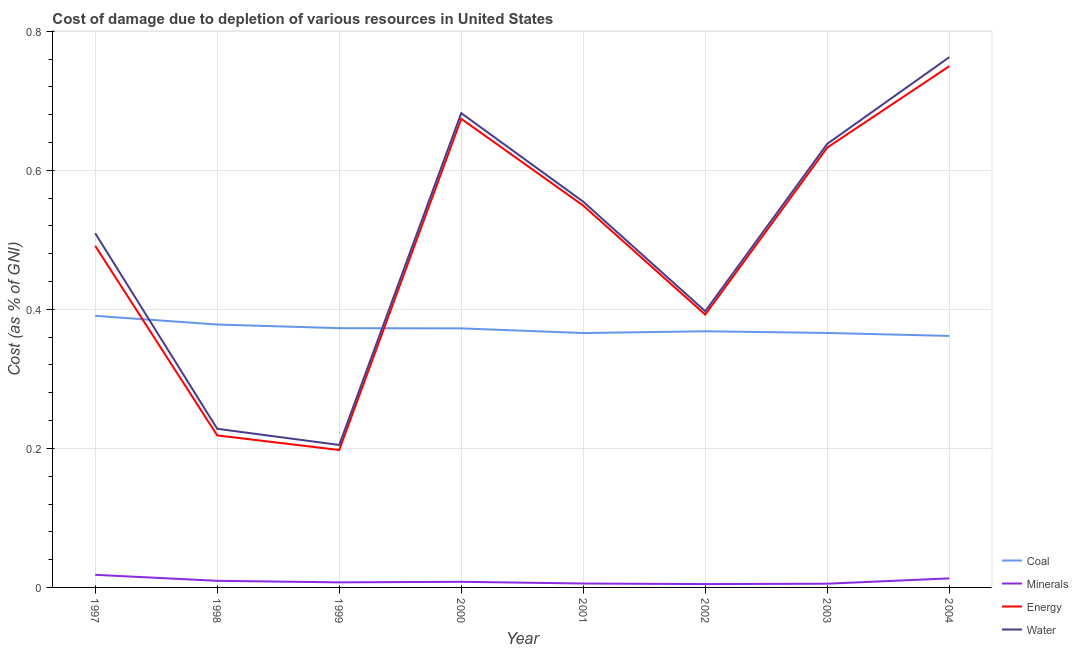What is the cost of damage due to depletion of coal in 2001?
Keep it short and to the point. 0.37. Across all years, what is the maximum cost of damage due to depletion of energy?
Give a very brief answer. 0.75. Across all years, what is the minimum cost of damage due to depletion of coal?
Offer a very short reply. 0.36. What is the total cost of damage due to depletion of water in the graph?
Give a very brief answer. 3.98. What is the difference between the cost of damage due to depletion of coal in 1999 and that in 2003?
Make the answer very short. 0.01. What is the difference between the cost of damage due to depletion of coal in 1997 and the cost of damage due to depletion of minerals in 2004?
Offer a very short reply. 0.38. What is the average cost of damage due to depletion of minerals per year?
Provide a short and direct response. 0.01. In the year 2004, what is the difference between the cost of damage due to depletion of minerals and cost of damage due to depletion of energy?
Make the answer very short. -0.74. In how many years, is the cost of damage due to depletion of energy greater than 0.36 %?
Offer a terse response. 6. What is the ratio of the cost of damage due to depletion of coal in 2002 to that in 2003?
Keep it short and to the point. 1.01. Is the cost of damage due to depletion of coal in 2000 less than that in 2001?
Make the answer very short. No. Is the difference between the cost of damage due to depletion of minerals in 1998 and 2000 greater than the difference between the cost of damage due to depletion of coal in 1998 and 2000?
Provide a short and direct response. No. What is the difference between the highest and the second highest cost of damage due to depletion of minerals?
Provide a short and direct response. 0.01. What is the difference between the highest and the lowest cost of damage due to depletion of coal?
Provide a succinct answer. 0.03. In how many years, is the cost of damage due to depletion of energy greater than the average cost of damage due to depletion of energy taken over all years?
Offer a very short reply. 5. Is the sum of the cost of damage due to depletion of coal in 2002 and 2004 greater than the maximum cost of damage due to depletion of water across all years?
Offer a terse response. No. Is it the case that in every year, the sum of the cost of damage due to depletion of minerals and cost of damage due to depletion of energy is greater than the sum of cost of damage due to depletion of coal and cost of damage due to depletion of water?
Offer a terse response. No. Does the cost of damage due to depletion of coal monotonically increase over the years?
Ensure brevity in your answer.  No. How many lines are there?
Make the answer very short. 4. How many years are there in the graph?
Your answer should be compact. 8. Does the graph contain any zero values?
Provide a short and direct response. No. How are the legend labels stacked?
Make the answer very short. Vertical. What is the title of the graph?
Keep it short and to the point. Cost of damage due to depletion of various resources in United States . What is the label or title of the X-axis?
Offer a terse response. Year. What is the label or title of the Y-axis?
Keep it short and to the point. Cost (as % of GNI). What is the Cost (as % of GNI) of Coal in 1997?
Ensure brevity in your answer.  0.39. What is the Cost (as % of GNI) of Minerals in 1997?
Your answer should be very brief. 0.02. What is the Cost (as % of GNI) in Energy in 1997?
Ensure brevity in your answer.  0.49. What is the Cost (as % of GNI) in Water in 1997?
Offer a very short reply. 0.51. What is the Cost (as % of GNI) of Coal in 1998?
Keep it short and to the point. 0.38. What is the Cost (as % of GNI) of Minerals in 1998?
Ensure brevity in your answer.  0.01. What is the Cost (as % of GNI) of Energy in 1998?
Offer a terse response. 0.22. What is the Cost (as % of GNI) of Water in 1998?
Provide a short and direct response. 0.23. What is the Cost (as % of GNI) of Coal in 1999?
Give a very brief answer. 0.37. What is the Cost (as % of GNI) of Minerals in 1999?
Provide a short and direct response. 0.01. What is the Cost (as % of GNI) of Energy in 1999?
Your answer should be very brief. 0.2. What is the Cost (as % of GNI) of Water in 1999?
Provide a succinct answer. 0.2. What is the Cost (as % of GNI) in Coal in 2000?
Your answer should be compact. 0.37. What is the Cost (as % of GNI) of Minerals in 2000?
Ensure brevity in your answer.  0.01. What is the Cost (as % of GNI) of Energy in 2000?
Keep it short and to the point. 0.67. What is the Cost (as % of GNI) of Water in 2000?
Give a very brief answer. 0.68. What is the Cost (as % of GNI) in Coal in 2001?
Offer a very short reply. 0.37. What is the Cost (as % of GNI) in Minerals in 2001?
Your response must be concise. 0.01. What is the Cost (as % of GNI) of Energy in 2001?
Your answer should be very brief. 0.55. What is the Cost (as % of GNI) of Water in 2001?
Your response must be concise. 0.55. What is the Cost (as % of GNI) of Coal in 2002?
Offer a very short reply. 0.37. What is the Cost (as % of GNI) of Minerals in 2002?
Offer a very short reply. 0. What is the Cost (as % of GNI) in Energy in 2002?
Your answer should be compact. 0.39. What is the Cost (as % of GNI) in Water in 2002?
Provide a succinct answer. 0.4. What is the Cost (as % of GNI) of Coal in 2003?
Make the answer very short. 0.37. What is the Cost (as % of GNI) of Minerals in 2003?
Provide a succinct answer. 0.01. What is the Cost (as % of GNI) of Energy in 2003?
Make the answer very short. 0.63. What is the Cost (as % of GNI) in Water in 2003?
Keep it short and to the point. 0.64. What is the Cost (as % of GNI) of Coal in 2004?
Offer a terse response. 0.36. What is the Cost (as % of GNI) of Minerals in 2004?
Make the answer very short. 0.01. What is the Cost (as % of GNI) in Energy in 2004?
Provide a short and direct response. 0.75. What is the Cost (as % of GNI) of Water in 2004?
Offer a very short reply. 0.76. Across all years, what is the maximum Cost (as % of GNI) in Coal?
Ensure brevity in your answer.  0.39. Across all years, what is the maximum Cost (as % of GNI) of Minerals?
Keep it short and to the point. 0.02. Across all years, what is the maximum Cost (as % of GNI) of Energy?
Give a very brief answer. 0.75. Across all years, what is the maximum Cost (as % of GNI) of Water?
Your answer should be very brief. 0.76. Across all years, what is the minimum Cost (as % of GNI) of Coal?
Offer a very short reply. 0.36. Across all years, what is the minimum Cost (as % of GNI) in Minerals?
Ensure brevity in your answer.  0. Across all years, what is the minimum Cost (as % of GNI) of Energy?
Give a very brief answer. 0.2. Across all years, what is the minimum Cost (as % of GNI) in Water?
Give a very brief answer. 0.2. What is the total Cost (as % of GNI) of Coal in the graph?
Give a very brief answer. 2.98. What is the total Cost (as % of GNI) in Minerals in the graph?
Make the answer very short. 0.07. What is the total Cost (as % of GNI) of Energy in the graph?
Make the answer very short. 3.91. What is the total Cost (as % of GNI) of Water in the graph?
Keep it short and to the point. 3.98. What is the difference between the Cost (as % of GNI) of Coal in 1997 and that in 1998?
Provide a short and direct response. 0.01. What is the difference between the Cost (as % of GNI) in Minerals in 1997 and that in 1998?
Provide a succinct answer. 0.01. What is the difference between the Cost (as % of GNI) of Energy in 1997 and that in 1998?
Your answer should be very brief. 0.27. What is the difference between the Cost (as % of GNI) in Water in 1997 and that in 1998?
Ensure brevity in your answer.  0.28. What is the difference between the Cost (as % of GNI) of Coal in 1997 and that in 1999?
Ensure brevity in your answer.  0.02. What is the difference between the Cost (as % of GNI) in Minerals in 1997 and that in 1999?
Make the answer very short. 0.01. What is the difference between the Cost (as % of GNI) of Energy in 1997 and that in 1999?
Offer a very short reply. 0.29. What is the difference between the Cost (as % of GNI) of Water in 1997 and that in 1999?
Keep it short and to the point. 0.3. What is the difference between the Cost (as % of GNI) of Coal in 1997 and that in 2000?
Keep it short and to the point. 0.02. What is the difference between the Cost (as % of GNI) in Energy in 1997 and that in 2000?
Give a very brief answer. -0.18. What is the difference between the Cost (as % of GNI) of Water in 1997 and that in 2000?
Keep it short and to the point. -0.17. What is the difference between the Cost (as % of GNI) in Coal in 1997 and that in 2001?
Your answer should be very brief. 0.02. What is the difference between the Cost (as % of GNI) in Minerals in 1997 and that in 2001?
Your answer should be compact. 0.01. What is the difference between the Cost (as % of GNI) in Energy in 1997 and that in 2001?
Your answer should be compact. -0.06. What is the difference between the Cost (as % of GNI) in Water in 1997 and that in 2001?
Ensure brevity in your answer.  -0.05. What is the difference between the Cost (as % of GNI) in Coal in 1997 and that in 2002?
Your answer should be compact. 0.02. What is the difference between the Cost (as % of GNI) in Minerals in 1997 and that in 2002?
Make the answer very short. 0.01. What is the difference between the Cost (as % of GNI) in Energy in 1997 and that in 2002?
Make the answer very short. 0.1. What is the difference between the Cost (as % of GNI) of Water in 1997 and that in 2002?
Keep it short and to the point. 0.11. What is the difference between the Cost (as % of GNI) in Coal in 1997 and that in 2003?
Offer a terse response. 0.02. What is the difference between the Cost (as % of GNI) in Minerals in 1997 and that in 2003?
Offer a very short reply. 0.01. What is the difference between the Cost (as % of GNI) in Energy in 1997 and that in 2003?
Provide a succinct answer. -0.14. What is the difference between the Cost (as % of GNI) of Water in 1997 and that in 2003?
Your answer should be very brief. -0.13. What is the difference between the Cost (as % of GNI) in Coal in 1997 and that in 2004?
Provide a succinct answer. 0.03. What is the difference between the Cost (as % of GNI) of Minerals in 1997 and that in 2004?
Ensure brevity in your answer.  0.01. What is the difference between the Cost (as % of GNI) of Energy in 1997 and that in 2004?
Give a very brief answer. -0.26. What is the difference between the Cost (as % of GNI) in Water in 1997 and that in 2004?
Offer a very short reply. -0.25. What is the difference between the Cost (as % of GNI) of Coal in 1998 and that in 1999?
Give a very brief answer. 0.01. What is the difference between the Cost (as % of GNI) of Minerals in 1998 and that in 1999?
Ensure brevity in your answer.  0. What is the difference between the Cost (as % of GNI) of Energy in 1998 and that in 1999?
Provide a succinct answer. 0.02. What is the difference between the Cost (as % of GNI) of Water in 1998 and that in 1999?
Your answer should be very brief. 0.02. What is the difference between the Cost (as % of GNI) of Coal in 1998 and that in 2000?
Your answer should be very brief. 0.01. What is the difference between the Cost (as % of GNI) in Minerals in 1998 and that in 2000?
Your response must be concise. 0. What is the difference between the Cost (as % of GNI) of Energy in 1998 and that in 2000?
Your answer should be compact. -0.46. What is the difference between the Cost (as % of GNI) in Water in 1998 and that in 2000?
Your response must be concise. -0.45. What is the difference between the Cost (as % of GNI) of Coal in 1998 and that in 2001?
Your answer should be very brief. 0.01. What is the difference between the Cost (as % of GNI) of Minerals in 1998 and that in 2001?
Ensure brevity in your answer.  0. What is the difference between the Cost (as % of GNI) in Energy in 1998 and that in 2001?
Provide a succinct answer. -0.33. What is the difference between the Cost (as % of GNI) in Water in 1998 and that in 2001?
Keep it short and to the point. -0.33. What is the difference between the Cost (as % of GNI) of Coal in 1998 and that in 2002?
Offer a very short reply. 0.01. What is the difference between the Cost (as % of GNI) of Minerals in 1998 and that in 2002?
Keep it short and to the point. 0. What is the difference between the Cost (as % of GNI) of Energy in 1998 and that in 2002?
Provide a short and direct response. -0.17. What is the difference between the Cost (as % of GNI) of Water in 1998 and that in 2002?
Your answer should be compact. -0.17. What is the difference between the Cost (as % of GNI) of Coal in 1998 and that in 2003?
Your response must be concise. 0.01. What is the difference between the Cost (as % of GNI) in Minerals in 1998 and that in 2003?
Your response must be concise. 0. What is the difference between the Cost (as % of GNI) of Energy in 1998 and that in 2003?
Provide a short and direct response. -0.41. What is the difference between the Cost (as % of GNI) in Water in 1998 and that in 2003?
Your answer should be very brief. -0.41. What is the difference between the Cost (as % of GNI) in Coal in 1998 and that in 2004?
Offer a very short reply. 0.02. What is the difference between the Cost (as % of GNI) of Minerals in 1998 and that in 2004?
Keep it short and to the point. -0. What is the difference between the Cost (as % of GNI) in Energy in 1998 and that in 2004?
Ensure brevity in your answer.  -0.53. What is the difference between the Cost (as % of GNI) of Water in 1998 and that in 2004?
Keep it short and to the point. -0.53. What is the difference between the Cost (as % of GNI) of Coal in 1999 and that in 2000?
Offer a terse response. 0. What is the difference between the Cost (as % of GNI) of Minerals in 1999 and that in 2000?
Your answer should be compact. -0. What is the difference between the Cost (as % of GNI) of Energy in 1999 and that in 2000?
Provide a succinct answer. -0.48. What is the difference between the Cost (as % of GNI) of Water in 1999 and that in 2000?
Keep it short and to the point. -0.48. What is the difference between the Cost (as % of GNI) of Coal in 1999 and that in 2001?
Give a very brief answer. 0.01. What is the difference between the Cost (as % of GNI) of Minerals in 1999 and that in 2001?
Your answer should be compact. 0. What is the difference between the Cost (as % of GNI) of Energy in 1999 and that in 2001?
Your answer should be compact. -0.35. What is the difference between the Cost (as % of GNI) in Water in 1999 and that in 2001?
Offer a very short reply. -0.35. What is the difference between the Cost (as % of GNI) in Coal in 1999 and that in 2002?
Provide a succinct answer. 0. What is the difference between the Cost (as % of GNI) in Minerals in 1999 and that in 2002?
Your response must be concise. 0. What is the difference between the Cost (as % of GNI) in Energy in 1999 and that in 2002?
Provide a succinct answer. -0.19. What is the difference between the Cost (as % of GNI) of Water in 1999 and that in 2002?
Offer a very short reply. -0.19. What is the difference between the Cost (as % of GNI) of Coal in 1999 and that in 2003?
Offer a terse response. 0.01. What is the difference between the Cost (as % of GNI) in Minerals in 1999 and that in 2003?
Your answer should be compact. 0. What is the difference between the Cost (as % of GNI) in Energy in 1999 and that in 2003?
Offer a terse response. -0.44. What is the difference between the Cost (as % of GNI) of Water in 1999 and that in 2003?
Keep it short and to the point. -0.43. What is the difference between the Cost (as % of GNI) in Coal in 1999 and that in 2004?
Your answer should be compact. 0.01. What is the difference between the Cost (as % of GNI) in Minerals in 1999 and that in 2004?
Keep it short and to the point. -0.01. What is the difference between the Cost (as % of GNI) in Energy in 1999 and that in 2004?
Your response must be concise. -0.55. What is the difference between the Cost (as % of GNI) in Water in 1999 and that in 2004?
Offer a terse response. -0.56. What is the difference between the Cost (as % of GNI) of Coal in 2000 and that in 2001?
Offer a terse response. 0.01. What is the difference between the Cost (as % of GNI) of Minerals in 2000 and that in 2001?
Keep it short and to the point. 0. What is the difference between the Cost (as % of GNI) in Energy in 2000 and that in 2001?
Ensure brevity in your answer.  0.12. What is the difference between the Cost (as % of GNI) of Water in 2000 and that in 2001?
Offer a terse response. 0.13. What is the difference between the Cost (as % of GNI) in Coal in 2000 and that in 2002?
Keep it short and to the point. 0. What is the difference between the Cost (as % of GNI) in Minerals in 2000 and that in 2002?
Give a very brief answer. 0. What is the difference between the Cost (as % of GNI) in Energy in 2000 and that in 2002?
Provide a succinct answer. 0.28. What is the difference between the Cost (as % of GNI) of Water in 2000 and that in 2002?
Make the answer very short. 0.28. What is the difference between the Cost (as % of GNI) in Coal in 2000 and that in 2003?
Your answer should be compact. 0.01. What is the difference between the Cost (as % of GNI) in Minerals in 2000 and that in 2003?
Your answer should be very brief. 0. What is the difference between the Cost (as % of GNI) of Energy in 2000 and that in 2003?
Provide a succinct answer. 0.04. What is the difference between the Cost (as % of GNI) of Water in 2000 and that in 2003?
Make the answer very short. 0.04. What is the difference between the Cost (as % of GNI) of Coal in 2000 and that in 2004?
Ensure brevity in your answer.  0.01. What is the difference between the Cost (as % of GNI) of Minerals in 2000 and that in 2004?
Provide a short and direct response. -0. What is the difference between the Cost (as % of GNI) in Energy in 2000 and that in 2004?
Your answer should be compact. -0.08. What is the difference between the Cost (as % of GNI) of Water in 2000 and that in 2004?
Ensure brevity in your answer.  -0.08. What is the difference between the Cost (as % of GNI) of Coal in 2001 and that in 2002?
Provide a succinct answer. -0. What is the difference between the Cost (as % of GNI) in Minerals in 2001 and that in 2002?
Keep it short and to the point. 0. What is the difference between the Cost (as % of GNI) of Energy in 2001 and that in 2002?
Your response must be concise. 0.16. What is the difference between the Cost (as % of GNI) of Water in 2001 and that in 2002?
Your answer should be very brief. 0.16. What is the difference between the Cost (as % of GNI) of Coal in 2001 and that in 2003?
Provide a succinct answer. -0. What is the difference between the Cost (as % of GNI) in Minerals in 2001 and that in 2003?
Your answer should be very brief. 0. What is the difference between the Cost (as % of GNI) in Energy in 2001 and that in 2003?
Offer a very short reply. -0.08. What is the difference between the Cost (as % of GNI) in Water in 2001 and that in 2003?
Make the answer very short. -0.08. What is the difference between the Cost (as % of GNI) in Coal in 2001 and that in 2004?
Ensure brevity in your answer.  0. What is the difference between the Cost (as % of GNI) in Minerals in 2001 and that in 2004?
Offer a very short reply. -0.01. What is the difference between the Cost (as % of GNI) of Energy in 2001 and that in 2004?
Ensure brevity in your answer.  -0.2. What is the difference between the Cost (as % of GNI) in Water in 2001 and that in 2004?
Offer a terse response. -0.21. What is the difference between the Cost (as % of GNI) of Coal in 2002 and that in 2003?
Give a very brief answer. 0. What is the difference between the Cost (as % of GNI) in Minerals in 2002 and that in 2003?
Ensure brevity in your answer.  -0. What is the difference between the Cost (as % of GNI) in Energy in 2002 and that in 2003?
Offer a very short reply. -0.24. What is the difference between the Cost (as % of GNI) in Water in 2002 and that in 2003?
Provide a short and direct response. -0.24. What is the difference between the Cost (as % of GNI) in Coal in 2002 and that in 2004?
Your answer should be very brief. 0.01. What is the difference between the Cost (as % of GNI) of Minerals in 2002 and that in 2004?
Your response must be concise. -0.01. What is the difference between the Cost (as % of GNI) of Energy in 2002 and that in 2004?
Offer a very short reply. -0.36. What is the difference between the Cost (as % of GNI) of Water in 2002 and that in 2004?
Your answer should be compact. -0.37. What is the difference between the Cost (as % of GNI) in Coal in 2003 and that in 2004?
Keep it short and to the point. 0. What is the difference between the Cost (as % of GNI) of Minerals in 2003 and that in 2004?
Ensure brevity in your answer.  -0.01. What is the difference between the Cost (as % of GNI) in Energy in 2003 and that in 2004?
Your response must be concise. -0.12. What is the difference between the Cost (as % of GNI) of Water in 2003 and that in 2004?
Keep it short and to the point. -0.12. What is the difference between the Cost (as % of GNI) of Coal in 1997 and the Cost (as % of GNI) of Minerals in 1998?
Your answer should be very brief. 0.38. What is the difference between the Cost (as % of GNI) in Coal in 1997 and the Cost (as % of GNI) in Energy in 1998?
Keep it short and to the point. 0.17. What is the difference between the Cost (as % of GNI) of Coal in 1997 and the Cost (as % of GNI) of Water in 1998?
Your response must be concise. 0.16. What is the difference between the Cost (as % of GNI) in Minerals in 1997 and the Cost (as % of GNI) in Energy in 1998?
Provide a succinct answer. -0.2. What is the difference between the Cost (as % of GNI) of Minerals in 1997 and the Cost (as % of GNI) of Water in 1998?
Give a very brief answer. -0.21. What is the difference between the Cost (as % of GNI) in Energy in 1997 and the Cost (as % of GNI) in Water in 1998?
Offer a terse response. 0.26. What is the difference between the Cost (as % of GNI) in Coal in 1997 and the Cost (as % of GNI) in Minerals in 1999?
Your response must be concise. 0.38. What is the difference between the Cost (as % of GNI) of Coal in 1997 and the Cost (as % of GNI) of Energy in 1999?
Your answer should be very brief. 0.19. What is the difference between the Cost (as % of GNI) in Coal in 1997 and the Cost (as % of GNI) in Water in 1999?
Your answer should be very brief. 0.19. What is the difference between the Cost (as % of GNI) in Minerals in 1997 and the Cost (as % of GNI) in Energy in 1999?
Provide a short and direct response. -0.18. What is the difference between the Cost (as % of GNI) of Minerals in 1997 and the Cost (as % of GNI) of Water in 1999?
Make the answer very short. -0.19. What is the difference between the Cost (as % of GNI) in Energy in 1997 and the Cost (as % of GNI) in Water in 1999?
Provide a short and direct response. 0.29. What is the difference between the Cost (as % of GNI) of Coal in 1997 and the Cost (as % of GNI) of Minerals in 2000?
Your answer should be very brief. 0.38. What is the difference between the Cost (as % of GNI) in Coal in 1997 and the Cost (as % of GNI) in Energy in 2000?
Provide a short and direct response. -0.28. What is the difference between the Cost (as % of GNI) of Coal in 1997 and the Cost (as % of GNI) of Water in 2000?
Your response must be concise. -0.29. What is the difference between the Cost (as % of GNI) of Minerals in 1997 and the Cost (as % of GNI) of Energy in 2000?
Ensure brevity in your answer.  -0.66. What is the difference between the Cost (as % of GNI) in Minerals in 1997 and the Cost (as % of GNI) in Water in 2000?
Provide a succinct answer. -0.66. What is the difference between the Cost (as % of GNI) of Energy in 1997 and the Cost (as % of GNI) of Water in 2000?
Make the answer very short. -0.19. What is the difference between the Cost (as % of GNI) of Coal in 1997 and the Cost (as % of GNI) of Minerals in 2001?
Your answer should be compact. 0.39. What is the difference between the Cost (as % of GNI) of Coal in 1997 and the Cost (as % of GNI) of Energy in 2001?
Offer a very short reply. -0.16. What is the difference between the Cost (as % of GNI) in Coal in 1997 and the Cost (as % of GNI) in Water in 2001?
Make the answer very short. -0.16. What is the difference between the Cost (as % of GNI) in Minerals in 1997 and the Cost (as % of GNI) in Energy in 2001?
Ensure brevity in your answer.  -0.53. What is the difference between the Cost (as % of GNI) in Minerals in 1997 and the Cost (as % of GNI) in Water in 2001?
Ensure brevity in your answer.  -0.54. What is the difference between the Cost (as % of GNI) in Energy in 1997 and the Cost (as % of GNI) in Water in 2001?
Offer a terse response. -0.06. What is the difference between the Cost (as % of GNI) of Coal in 1997 and the Cost (as % of GNI) of Minerals in 2002?
Provide a short and direct response. 0.39. What is the difference between the Cost (as % of GNI) of Coal in 1997 and the Cost (as % of GNI) of Energy in 2002?
Your answer should be compact. -0. What is the difference between the Cost (as % of GNI) of Coal in 1997 and the Cost (as % of GNI) of Water in 2002?
Offer a terse response. -0.01. What is the difference between the Cost (as % of GNI) in Minerals in 1997 and the Cost (as % of GNI) in Energy in 2002?
Offer a very short reply. -0.37. What is the difference between the Cost (as % of GNI) in Minerals in 1997 and the Cost (as % of GNI) in Water in 2002?
Offer a very short reply. -0.38. What is the difference between the Cost (as % of GNI) in Energy in 1997 and the Cost (as % of GNI) in Water in 2002?
Provide a short and direct response. 0.09. What is the difference between the Cost (as % of GNI) of Coal in 1997 and the Cost (as % of GNI) of Minerals in 2003?
Make the answer very short. 0.39. What is the difference between the Cost (as % of GNI) of Coal in 1997 and the Cost (as % of GNI) of Energy in 2003?
Give a very brief answer. -0.24. What is the difference between the Cost (as % of GNI) in Coal in 1997 and the Cost (as % of GNI) in Water in 2003?
Offer a very short reply. -0.25. What is the difference between the Cost (as % of GNI) of Minerals in 1997 and the Cost (as % of GNI) of Energy in 2003?
Offer a terse response. -0.61. What is the difference between the Cost (as % of GNI) in Minerals in 1997 and the Cost (as % of GNI) in Water in 2003?
Provide a succinct answer. -0.62. What is the difference between the Cost (as % of GNI) of Energy in 1997 and the Cost (as % of GNI) of Water in 2003?
Provide a short and direct response. -0.15. What is the difference between the Cost (as % of GNI) in Coal in 1997 and the Cost (as % of GNI) in Minerals in 2004?
Your answer should be compact. 0.38. What is the difference between the Cost (as % of GNI) of Coal in 1997 and the Cost (as % of GNI) of Energy in 2004?
Make the answer very short. -0.36. What is the difference between the Cost (as % of GNI) in Coal in 1997 and the Cost (as % of GNI) in Water in 2004?
Keep it short and to the point. -0.37. What is the difference between the Cost (as % of GNI) of Minerals in 1997 and the Cost (as % of GNI) of Energy in 2004?
Your answer should be very brief. -0.73. What is the difference between the Cost (as % of GNI) in Minerals in 1997 and the Cost (as % of GNI) in Water in 2004?
Your answer should be very brief. -0.74. What is the difference between the Cost (as % of GNI) of Energy in 1997 and the Cost (as % of GNI) of Water in 2004?
Give a very brief answer. -0.27. What is the difference between the Cost (as % of GNI) in Coal in 1998 and the Cost (as % of GNI) in Minerals in 1999?
Offer a terse response. 0.37. What is the difference between the Cost (as % of GNI) in Coal in 1998 and the Cost (as % of GNI) in Energy in 1999?
Provide a succinct answer. 0.18. What is the difference between the Cost (as % of GNI) of Coal in 1998 and the Cost (as % of GNI) of Water in 1999?
Offer a very short reply. 0.17. What is the difference between the Cost (as % of GNI) of Minerals in 1998 and the Cost (as % of GNI) of Energy in 1999?
Offer a very short reply. -0.19. What is the difference between the Cost (as % of GNI) in Minerals in 1998 and the Cost (as % of GNI) in Water in 1999?
Offer a very short reply. -0.2. What is the difference between the Cost (as % of GNI) in Energy in 1998 and the Cost (as % of GNI) in Water in 1999?
Your answer should be compact. 0.01. What is the difference between the Cost (as % of GNI) in Coal in 1998 and the Cost (as % of GNI) in Minerals in 2000?
Ensure brevity in your answer.  0.37. What is the difference between the Cost (as % of GNI) in Coal in 1998 and the Cost (as % of GNI) in Energy in 2000?
Provide a succinct answer. -0.3. What is the difference between the Cost (as % of GNI) in Coal in 1998 and the Cost (as % of GNI) in Water in 2000?
Ensure brevity in your answer.  -0.3. What is the difference between the Cost (as % of GNI) of Minerals in 1998 and the Cost (as % of GNI) of Energy in 2000?
Ensure brevity in your answer.  -0.66. What is the difference between the Cost (as % of GNI) of Minerals in 1998 and the Cost (as % of GNI) of Water in 2000?
Provide a short and direct response. -0.67. What is the difference between the Cost (as % of GNI) of Energy in 1998 and the Cost (as % of GNI) of Water in 2000?
Give a very brief answer. -0.46. What is the difference between the Cost (as % of GNI) in Coal in 1998 and the Cost (as % of GNI) in Minerals in 2001?
Offer a terse response. 0.37. What is the difference between the Cost (as % of GNI) in Coal in 1998 and the Cost (as % of GNI) in Energy in 2001?
Make the answer very short. -0.17. What is the difference between the Cost (as % of GNI) in Coal in 1998 and the Cost (as % of GNI) in Water in 2001?
Give a very brief answer. -0.18. What is the difference between the Cost (as % of GNI) of Minerals in 1998 and the Cost (as % of GNI) of Energy in 2001?
Offer a terse response. -0.54. What is the difference between the Cost (as % of GNI) in Minerals in 1998 and the Cost (as % of GNI) in Water in 2001?
Your answer should be very brief. -0.55. What is the difference between the Cost (as % of GNI) in Energy in 1998 and the Cost (as % of GNI) in Water in 2001?
Ensure brevity in your answer.  -0.34. What is the difference between the Cost (as % of GNI) in Coal in 1998 and the Cost (as % of GNI) in Minerals in 2002?
Your answer should be compact. 0.37. What is the difference between the Cost (as % of GNI) of Coal in 1998 and the Cost (as % of GNI) of Energy in 2002?
Offer a very short reply. -0.01. What is the difference between the Cost (as % of GNI) in Coal in 1998 and the Cost (as % of GNI) in Water in 2002?
Make the answer very short. -0.02. What is the difference between the Cost (as % of GNI) in Minerals in 1998 and the Cost (as % of GNI) in Energy in 2002?
Offer a terse response. -0.38. What is the difference between the Cost (as % of GNI) in Minerals in 1998 and the Cost (as % of GNI) in Water in 2002?
Keep it short and to the point. -0.39. What is the difference between the Cost (as % of GNI) of Energy in 1998 and the Cost (as % of GNI) of Water in 2002?
Make the answer very short. -0.18. What is the difference between the Cost (as % of GNI) in Coal in 1998 and the Cost (as % of GNI) in Minerals in 2003?
Provide a short and direct response. 0.37. What is the difference between the Cost (as % of GNI) in Coal in 1998 and the Cost (as % of GNI) in Energy in 2003?
Give a very brief answer. -0.25. What is the difference between the Cost (as % of GNI) of Coal in 1998 and the Cost (as % of GNI) of Water in 2003?
Provide a succinct answer. -0.26. What is the difference between the Cost (as % of GNI) of Minerals in 1998 and the Cost (as % of GNI) of Energy in 2003?
Offer a terse response. -0.62. What is the difference between the Cost (as % of GNI) in Minerals in 1998 and the Cost (as % of GNI) in Water in 2003?
Ensure brevity in your answer.  -0.63. What is the difference between the Cost (as % of GNI) of Energy in 1998 and the Cost (as % of GNI) of Water in 2003?
Make the answer very short. -0.42. What is the difference between the Cost (as % of GNI) of Coal in 1998 and the Cost (as % of GNI) of Minerals in 2004?
Provide a succinct answer. 0.37. What is the difference between the Cost (as % of GNI) of Coal in 1998 and the Cost (as % of GNI) of Energy in 2004?
Make the answer very short. -0.37. What is the difference between the Cost (as % of GNI) of Coal in 1998 and the Cost (as % of GNI) of Water in 2004?
Your answer should be very brief. -0.38. What is the difference between the Cost (as % of GNI) of Minerals in 1998 and the Cost (as % of GNI) of Energy in 2004?
Your response must be concise. -0.74. What is the difference between the Cost (as % of GNI) of Minerals in 1998 and the Cost (as % of GNI) of Water in 2004?
Give a very brief answer. -0.75. What is the difference between the Cost (as % of GNI) in Energy in 1998 and the Cost (as % of GNI) in Water in 2004?
Provide a short and direct response. -0.54. What is the difference between the Cost (as % of GNI) in Coal in 1999 and the Cost (as % of GNI) in Minerals in 2000?
Offer a very short reply. 0.36. What is the difference between the Cost (as % of GNI) of Coal in 1999 and the Cost (as % of GNI) of Energy in 2000?
Give a very brief answer. -0.3. What is the difference between the Cost (as % of GNI) of Coal in 1999 and the Cost (as % of GNI) of Water in 2000?
Offer a very short reply. -0.31. What is the difference between the Cost (as % of GNI) in Minerals in 1999 and the Cost (as % of GNI) in Energy in 2000?
Provide a short and direct response. -0.67. What is the difference between the Cost (as % of GNI) in Minerals in 1999 and the Cost (as % of GNI) in Water in 2000?
Ensure brevity in your answer.  -0.67. What is the difference between the Cost (as % of GNI) of Energy in 1999 and the Cost (as % of GNI) of Water in 2000?
Ensure brevity in your answer.  -0.48. What is the difference between the Cost (as % of GNI) of Coal in 1999 and the Cost (as % of GNI) of Minerals in 2001?
Provide a short and direct response. 0.37. What is the difference between the Cost (as % of GNI) of Coal in 1999 and the Cost (as % of GNI) of Energy in 2001?
Provide a short and direct response. -0.18. What is the difference between the Cost (as % of GNI) in Coal in 1999 and the Cost (as % of GNI) in Water in 2001?
Ensure brevity in your answer.  -0.18. What is the difference between the Cost (as % of GNI) of Minerals in 1999 and the Cost (as % of GNI) of Energy in 2001?
Your answer should be compact. -0.54. What is the difference between the Cost (as % of GNI) in Minerals in 1999 and the Cost (as % of GNI) in Water in 2001?
Your answer should be very brief. -0.55. What is the difference between the Cost (as % of GNI) of Energy in 1999 and the Cost (as % of GNI) of Water in 2001?
Your answer should be compact. -0.36. What is the difference between the Cost (as % of GNI) of Coal in 1999 and the Cost (as % of GNI) of Minerals in 2002?
Ensure brevity in your answer.  0.37. What is the difference between the Cost (as % of GNI) of Coal in 1999 and the Cost (as % of GNI) of Energy in 2002?
Ensure brevity in your answer.  -0.02. What is the difference between the Cost (as % of GNI) in Coal in 1999 and the Cost (as % of GNI) in Water in 2002?
Provide a short and direct response. -0.02. What is the difference between the Cost (as % of GNI) in Minerals in 1999 and the Cost (as % of GNI) in Energy in 2002?
Make the answer very short. -0.39. What is the difference between the Cost (as % of GNI) of Minerals in 1999 and the Cost (as % of GNI) of Water in 2002?
Offer a terse response. -0.39. What is the difference between the Cost (as % of GNI) of Energy in 1999 and the Cost (as % of GNI) of Water in 2002?
Provide a succinct answer. -0.2. What is the difference between the Cost (as % of GNI) of Coal in 1999 and the Cost (as % of GNI) of Minerals in 2003?
Keep it short and to the point. 0.37. What is the difference between the Cost (as % of GNI) of Coal in 1999 and the Cost (as % of GNI) of Energy in 2003?
Offer a terse response. -0.26. What is the difference between the Cost (as % of GNI) of Coal in 1999 and the Cost (as % of GNI) of Water in 2003?
Provide a succinct answer. -0.27. What is the difference between the Cost (as % of GNI) of Minerals in 1999 and the Cost (as % of GNI) of Energy in 2003?
Your answer should be compact. -0.63. What is the difference between the Cost (as % of GNI) in Minerals in 1999 and the Cost (as % of GNI) in Water in 2003?
Provide a short and direct response. -0.63. What is the difference between the Cost (as % of GNI) of Energy in 1999 and the Cost (as % of GNI) of Water in 2003?
Provide a short and direct response. -0.44. What is the difference between the Cost (as % of GNI) of Coal in 1999 and the Cost (as % of GNI) of Minerals in 2004?
Your answer should be compact. 0.36. What is the difference between the Cost (as % of GNI) in Coal in 1999 and the Cost (as % of GNI) in Energy in 2004?
Offer a terse response. -0.38. What is the difference between the Cost (as % of GNI) of Coal in 1999 and the Cost (as % of GNI) of Water in 2004?
Give a very brief answer. -0.39. What is the difference between the Cost (as % of GNI) in Minerals in 1999 and the Cost (as % of GNI) in Energy in 2004?
Provide a short and direct response. -0.74. What is the difference between the Cost (as % of GNI) of Minerals in 1999 and the Cost (as % of GNI) of Water in 2004?
Your answer should be compact. -0.76. What is the difference between the Cost (as % of GNI) of Energy in 1999 and the Cost (as % of GNI) of Water in 2004?
Keep it short and to the point. -0.57. What is the difference between the Cost (as % of GNI) in Coal in 2000 and the Cost (as % of GNI) in Minerals in 2001?
Your answer should be compact. 0.37. What is the difference between the Cost (as % of GNI) in Coal in 2000 and the Cost (as % of GNI) in Energy in 2001?
Keep it short and to the point. -0.18. What is the difference between the Cost (as % of GNI) of Coal in 2000 and the Cost (as % of GNI) of Water in 2001?
Provide a short and direct response. -0.18. What is the difference between the Cost (as % of GNI) of Minerals in 2000 and the Cost (as % of GNI) of Energy in 2001?
Your response must be concise. -0.54. What is the difference between the Cost (as % of GNI) in Minerals in 2000 and the Cost (as % of GNI) in Water in 2001?
Offer a terse response. -0.55. What is the difference between the Cost (as % of GNI) of Energy in 2000 and the Cost (as % of GNI) of Water in 2001?
Your answer should be compact. 0.12. What is the difference between the Cost (as % of GNI) in Coal in 2000 and the Cost (as % of GNI) in Minerals in 2002?
Make the answer very short. 0.37. What is the difference between the Cost (as % of GNI) of Coal in 2000 and the Cost (as % of GNI) of Energy in 2002?
Make the answer very short. -0.02. What is the difference between the Cost (as % of GNI) of Coal in 2000 and the Cost (as % of GNI) of Water in 2002?
Your answer should be very brief. -0.02. What is the difference between the Cost (as % of GNI) in Minerals in 2000 and the Cost (as % of GNI) in Energy in 2002?
Your answer should be compact. -0.38. What is the difference between the Cost (as % of GNI) in Minerals in 2000 and the Cost (as % of GNI) in Water in 2002?
Your answer should be compact. -0.39. What is the difference between the Cost (as % of GNI) of Energy in 2000 and the Cost (as % of GNI) of Water in 2002?
Your response must be concise. 0.28. What is the difference between the Cost (as % of GNI) of Coal in 2000 and the Cost (as % of GNI) of Minerals in 2003?
Keep it short and to the point. 0.37. What is the difference between the Cost (as % of GNI) in Coal in 2000 and the Cost (as % of GNI) in Energy in 2003?
Provide a short and direct response. -0.26. What is the difference between the Cost (as % of GNI) in Coal in 2000 and the Cost (as % of GNI) in Water in 2003?
Offer a terse response. -0.27. What is the difference between the Cost (as % of GNI) in Minerals in 2000 and the Cost (as % of GNI) in Energy in 2003?
Your answer should be very brief. -0.62. What is the difference between the Cost (as % of GNI) in Minerals in 2000 and the Cost (as % of GNI) in Water in 2003?
Make the answer very short. -0.63. What is the difference between the Cost (as % of GNI) of Energy in 2000 and the Cost (as % of GNI) of Water in 2003?
Offer a terse response. 0.04. What is the difference between the Cost (as % of GNI) of Coal in 2000 and the Cost (as % of GNI) of Minerals in 2004?
Your answer should be compact. 0.36. What is the difference between the Cost (as % of GNI) of Coal in 2000 and the Cost (as % of GNI) of Energy in 2004?
Offer a very short reply. -0.38. What is the difference between the Cost (as % of GNI) of Coal in 2000 and the Cost (as % of GNI) of Water in 2004?
Ensure brevity in your answer.  -0.39. What is the difference between the Cost (as % of GNI) of Minerals in 2000 and the Cost (as % of GNI) of Energy in 2004?
Your answer should be compact. -0.74. What is the difference between the Cost (as % of GNI) of Minerals in 2000 and the Cost (as % of GNI) of Water in 2004?
Provide a short and direct response. -0.75. What is the difference between the Cost (as % of GNI) of Energy in 2000 and the Cost (as % of GNI) of Water in 2004?
Your response must be concise. -0.09. What is the difference between the Cost (as % of GNI) in Coal in 2001 and the Cost (as % of GNI) in Minerals in 2002?
Offer a very short reply. 0.36. What is the difference between the Cost (as % of GNI) in Coal in 2001 and the Cost (as % of GNI) in Energy in 2002?
Give a very brief answer. -0.03. What is the difference between the Cost (as % of GNI) in Coal in 2001 and the Cost (as % of GNI) in Water in 2002?
Your answer should be compact. -0.03. What is the difference between the Cost (as % of GNI) of Minerals in 2001 and the Cost (as % of GNI) of Energy in 2002?
Give a very brief answer. -0.39. What is the difference between the Cost (as % of GNI) of Minerals in 2001 and the Cost (as % of GNI) of Water in 2002?
Make the answer very short. -0.39. What is the difference between the Cost (as % of GNI) of Energy in 2001 and the Cost (as % of GNI) of Water in 2002?
Give a very brief answer. 0.15. What is the difference between the Cost (as % of GNI) of Coal in 2001 and the Cost (as % of GNI) of Minerals in 2003?
Your response must be concise. 0.36. What is the difference between the Cost (as % of GNI) in Coal in 2001 and the Cost (as % of GNI) in Energy in 2003?
Your response must be concise. -0.27. What is the difference between the Cost (as % of GNI) in Coal in 2001 and the Cost (as % of GNI) in Water in 2003?
Your answer should be compact. -0.27. What is the difference between the Cost (as % of GNI) in Minerals in 2001 and the Cost (as % of GNI) in Energy in 2003?
Make the answer very short. -0.63. What is the difference between the Cost (as % of GNI) in Minerals in 2001 and the Cost (as % of GNI) in Water in 2003?
Your answer should be very brief. -0.63. What is the difference between the Cost (as % of GNI) in Energy in 2001 and the Cost (as % of GNI) in Water in 2003?
Give a very brief answer. -0.09. What is the difference between the Cost (as % of GNI) in Coal in 2001 and the Cost (as % of GNI) in Minerals in 2004?
Offer a terse response. 0.35. What is the difference between the Cost (as % of GNI) of Coal in 2001 and the Cost (as % of GNI) of Energy in 2004?
Ensure brevity in your answer.  -0.38. What is the difference between the Cost (as % of GNI) in Coal in 2001 and the Cost (as % of GNI) in Water in 2004?
Offer a very short reply. -0.4. What is the difference between the Cost (as % of GNI) in Minerals in 2001 and the Cost (as % of GNI) in Energy in 2004?
Make the answer very short. -0.74. What is the difference between the Cost (as % of GNI) in Minerals in 2001 and the Cost (as % of GNI) in Water in 2004?
Offer a very short reply. -0.76. What is the difference between the Cost (as % of GNI) of Energy in 2001 and the Cost (as % of GNI) of Water in 2004?
Keep it short and to the point. -0.21. What is the difference between the Cost (as % of GNI) in Coal in 2002 and the Cost (as % of GNI) in Minerals in 2003?
Make the answer very short. 0.36. What is the difference between the Cost (as % of GNI) of Coal in 2002 and the Cost (as % of GNI) of Energy in 2003?
Provide a succinct answer. -0.26. What is the difference between the Cost (as % of GNI) of Coal in 2002 and the Cost (as % of GNI) of Water in 2003?
Provide a short and direct response. -0.27. What is the difference between the Cost (as % of GNI) of Minerals in 2002 and the Cost (as % of GNI) of Energy in 2003?
Your response must be concise. -0.63. What is the difference between the Cost (as % of GNI) in Minerals in 2002 and the Cost (as % of GNI) in Water in 2003?
Offer a very short reply. -0.63. What is the difference between the Cost (as % of GNI) of Energy in 2002 and the Cost (as % of GNI) of Water in 2003?
Your response must be concise. -0.25. What is the difference between the Cost (as % of GNI) in Coal in 2002 and the Cost (as % of GNI) in Minerals in 2004?
Keep it short and to the point. 0.36. What is the difference between the Cost (as % of GNI) of Coal in 2002 and the Cost (as % of GNI) of Energy in 2004?
Give a very brief answer. -0.38. What is the difference between the Cost (as % of GNI) in Coal in 2002 and the Cost (as % of GNI) in Water in 2004?
Provide a short and direct response. -0.39. What is the difference between the Cost (as % of GNI) of Minerals in 2002 and the Cost (as % of GNI) of Energy in 2004?
Provide a succinct answer. -0.74. What is the difference between the Cost (as % of GNI) of Minerals in 2002 and the Cost (as % of GNI) of Water in 2004?
Offer a very short reply. -0.76. What is the difference between the Cost (as % of GNI) in Energy in 2002 and the Cost (as % of GNI) in Water in 2004?
Make the answer very short. -0.37. What is the difference between the Cost (as % of GNI) of Coal in 2003 and the Cost (as % of GNI) of Minerals in 2004?
Give a very brief answer. 0.35. What is the difference between the Cost (as % of GNI) of Coal in 2003 and the Cost (as % of GNI) of Energy in 2004?
Give a very brief answer. -0.38. What is the difference between the Cost (as % of GNI) of Coal in 2003 and the Cost (as % of GNI) of Water in 2004?
Keep it short and to the point. -0.4. What is the difference between the Cost (as % of GNI) in Minerals in 2003 and the Cost (as % of GNI) in Energy in 2004?
Provide a succinct answer. -0.74. What is the difference between the Cost (as % of GNI) in Minerals in 2003 and the Cost (as % of GNI) in Water in 2004?
Your answer should be compact. -0.76. What is the difference between the Cost (as % of GNI) of Energy in 2003 and the Cost (as % of GNI) of Water in 2004?
Provide a succinct answer. -0.13. What is the average Cost (as % of GNI) in Coal per year?
Keep it short and to the point. 0.37. What is the average Cost (as % of GNI) in Minerals per year?
Keep it short and to the point. 0.01. What is the average Cost (as % of GNI) of Energy per year?
Your answer should be compact. 0.49. What is the average Cost (as % of GNI) in Water per year?
Your answer should be very brief. 0.5. In the year 1997, what is the difference between the Cost (as % of GNI) in Coal and Cost (as % of GNI) in Minerals?
Ensure brevity in your answer.  0.37. In the year 1997, what is the difference between the Cost (as % of GNI) in Coal and Cost (as % of GNI) in Energy?
Ensure brevity in your answer.  -0.1. In the year 1997, what is the difference between the Cost (as % of GNI) in Coal and Cost (as % of GNI) in Water?
Offer a very short reply. -0.12. In the year 1997, what is the difference between the Cost (as % of GNI) of Minerals and Cost (as % of GNI) of Energy?
Your answer should be compact. -0.47. In the year 1997, what is the difference between the Cost (as % of GNI) in Minerals and Cost (as % of GNI) in Water?
Keep it short and to the point. -0.49. In the year 1997, what is the difference between the Cost (as % of GNI) in Energy and Cost (as % of GNI) in Water?
Offer a terse response. -0.02. In the year 1998, what is the difference between the Cost (as % of GNI) of Coal and Cost (as % of GNI) of Minerals?
Offer a terse response. 0.37. In the year 1998, what is the difference between the Cost (as % of GNI) in Coal and Cost (as % of GNI) in Energy?
Provide a short and direct response. 0.16. In the year 1998, what is the difference between the Cost (as % of GNI) in Minerals and Cost (as % of GNI) in Energy?
Offer a terse response. -0.21. In the year 1998, what is the difference between the Cost (as % of GNI) of Minerals and Cost (as % of GNI) of Water?
Offer a terse response. -0.22. In the year 1998, what is the difference between the Cost (as % of GNI) in Energy and Cost (as % of GNI) in Water?
Your response must be concise. -0.01. In the year 1999, what is the difference between the Cost (as % of GNI) in Coal and Cost (as % of GNI) in Minerals?
Your answer should be compact. 0.37. In the year 1999, what is the difference between the Cost (as % of GNI) of Coal and Cost (as % of GNI) of Energy?
Ensure brevity in your answer.  0.18. In the year 1999, what is the difference between the Cost (as % of GNI) of Coal and Cost (as % of GNI) of Water?
Provide a succinct answer. 0.17. In the year 1999, what is the difference between the Cost (as % of GNI) in Minerals and Cost (as % of GNI) in Energy?
Your answer should be compact. -0.19. In the year 1999, what is the difference between the Cost (as % of GNI) of Minerals and Cost (as % of GNI) of Water?
Provide a short and direct response. -0.2. In the year 1999, what is the difference between the Cost (as % of GNI) in Energy and Cost (as % of GNI) in Water?
Give a very brief answer. -0.01. In the year 2000, what is the difference between the Cost (as % of GNI) of Coal and Cost (as % of GNI) of Minerals?
Provide a short and direct response. 0.36. In the year 2000, what is the difference between the Cost (as % of GNI) of Coal and Cost (as % of GNI) of Energy?
Give a very brief answer. -0.3. In the year 2000, what is the difference between the Cost (as % of GNI) of Coal and Cost (as % of GNI) of Water?
Your answer should be compact. -0.31. In the year 2000, what is the difference between the Cost (as % of GNI) in Minerals and Cost (as % of GNI) in Energy?
Give a very brief answer. -0.67. In the year 2000, what is the difference between the Cost (as % of GNI) of Minerals and Cost (as % of GNI) of Water?
Make the answer very short. -0.67. In the year 2000, what is the difference between the Cost (as % of GNI) in Energy and Cost (as % of GNI) in Water?
Give a very brief answer. -0.01. In the year 2001, what is the difference between the Cost (as % of GNI) in Coal and Cost (as % of GNI) in Minerals?
Your answer should be compact. 0.36. In the year 2001, what is the difference between the Cost (as % of GNI) in Coal and Cost (as % of GNI) in Energy?
Offer a very short reply. -0.18. In the year 2001, what is the difference between the Cost (as % of GNI) in Coal and Cost (as % of GNI) in Water?
Provide a succinct answer. -0.19. In the year 2001, what is the difference between the Cost (as % of GNI) of Minerals and Cost (as % of GNI) of Energy?
Your answer should be compact. -0.54. In the year 2001, what is the difference between the Cost (as % of GNI) in Minerals and Cost (as % of GNI) in Water?
Ensure brevity in your answer.  -0.55. In the year 2001, what is the difference between the Cost (as % of GNI) in Energy and Cost (as % of GNI) in Water?
Keep it short and to the point. -0.01. In the year 2002, what is the difference between the Cost (as % of GNI) of Coal and Cost (as % of GNI) of Minerals?
Make the answer very short. 0.36. In the year 2002, what is the difference between the Cost (as % of GNI) in Coal and Cost (as % of GNI) in Energy?
Offer a very short reply. -0.02. In the year 2002, what is the difference between the Cost (as % of GNI) of Coal and Cost (as % of GNI) of Water?
Keep it short and to the point. -0.03. In the year 2002, what is the difference between the Cost (as % of GNI) of Minerals and Cost (as % of GNI) of Energy?
Your answer should be very brief. -0.39. In the year 2002, what is the difference between the Cost (as % of GNI) of Minerals and Cost (as % of GNI) of Water?
Provide a short and direct response. -0.39. In the year 2002, what is the difference between the Cost (as % of GNI) of Energy and Cost (as % of GNI) of Water?
Provide a short and direct response. -0. In the year 2003, what is the difference between the Cost (as % of GNI) in Coal and Cost (as % of GNI) in Minerals?
Give a very brief answer. 0.36. In the year 2003, what is the difference between the Cost (as % of GNI) of Coal and Cost (as % of GNI) of Energy?
Your answer should be very brief. -0.27. In the year 2003, what is the difference between the Cost (as % of GNI) of Coal and Cost (as % of GNI) of Water?
Offer a terse response. -0.27. In the year 2003, what is the difference between the Cost (as % of GNI) of Minerals and Cost (as % of GNI) of Energy?
Provide a short and direct response. -0.63. In the year 2003, what is the difference between the Cost (as % of GNI) in Minerals and Cost (as % of GNI) in Water?
Provide a short and direct response. -0.63. In the year 2003, what is the difference between the Cost (as % of GNI) of Energy and Cost (as % of GNI) of Water?
Provide a succinct answer. -0.01. In the year 2004, what is the difference between the Cost (as % of GNI) in Coal and Cost (as % of GNI) in Minerals?
Your response must be concise. 0.35. In the year 2004, what is the difference between the Cost (as % of GNI) in Coal and Cost (as % of GNI) in Energy?
Provide a short and direct response. -0.39. In the year 2004, what is the difference between the Cost (as % of GNI) of Coal and Cost (as % of GNI) of Water?
Offer a terse response. -0.4. In the year 2004, what is the difference between the Cost (as % of GNI) in Minerals and Cost (as % of GNI) in Energy?
Make the answer very short. -0.74. In the year 2004, what is the difference between the Cost (as % of GNI) of Minerals and Cost (as % of GNI) of Water?
Provide a succinct answer. -0.75. In the year 2004, what is the difference between the Cost (as % of GNI) in Energy and Cost (as % of GNI) in Water?
Keep it short and to the point. -0.01. What is the ratio of the Cost (as % of GNI) of Coal in 1997 to that in 1998?
Give a very brief answer. 1.03. What is the ratio of the Cost (as % of GNI) in Minerals in 1997 to that in 1998?
Ensure brevity in your answer.  1.91. What is the ratio of the Cost (as % of GNI) in Energy in 1997 to that in 1998?
Ensure brevity in your answer.  2.25. What is the ratio of the Cost (as % of GNI) of Water in 1997 to that in 1998?
Your answer should be very brief. 2.23. What is the ratio of the Cost (as % of GNI) of Coal in 1997 to that in 1999?
Ensure brevity in your answer.  1.05. What is the ratio of the Cost (as % of GNI) in Minerals in 1997 to that in 1999?
Give a very brief answer. 2.49. What is the ratio of the Cost (as % of GNI) of Energy in 1997 to that in 1999?
Your answer should be very brief. 2.49. What is the ratio of the Cost (as % of GNI) of Water in 1997 to that in 1999?
Provide a succinct answer. 2.49. What is the ratio of the Cost (as % of GNI) in Coal in 1997 to that in 2000?
Your answer should be compact. 1.05. What is the ratio of the Cost (as % of GNI) in Minerals in 1997 to that in 2000?
Make the answer very short. 2.24. What is the ratio of the Cost (as % of GNI) in Energy in 1997 to that in 2000?
Offer a terse response. 0.73. What is the ratio of the Cost (as % of GNI) in Water in 1997 to that in 2000?
Your answer should be compact. 0.75. What is the ratio of the Cost (as % of GNI) of Coal in 1997 to that in 2001?
Keep it short and to the point. 1.07. What is the ratio of the Cost (as % of GNI) in Minerals in 1997 to that in 2001?
Keep it short and to the point. 3.22. What is the ratio of the Cost (as % of GNI) of Energy in 1997 to that in 2001?
Your answer should be compact. 0.89. What is the ratio of the Cost (as % of GNI) of Water in 1997 to that in 2001?
Your answer should be compact. 0.92. What is the ratio of the Cost (as % of GNI) of Coal in 1997 to that in 2002?
Give a very brief answer. 1.06. What is the ratio of the Cost (as % of GNI) of Minerals in 1997 to that in 2002?
Make the answer very short. 3.77. What is the ratio of the Cost (as % of GNI) of Energy in 1997 to that in 2002?
Give a very brief answer. 1.25. What is the ratio of the Cost (as % of GNI) in Water in 1997 to that in 2002?
Offer a terse response. 1.28. What is the ratio of the Cost (as % of GNI) of Coal in 1997 to that in 2003?
Keep it short and to the point. 1.07. What is the ratio of the Cost (as % of GNI) of Minerals in 1997 to that in 2003?
Make the answer very short. 3.39. What is the ratio of the Cost (as % of GNI) in Energy in 1997 to that in 2003?
Your answer should be compact. 0.78. What is the ratio of the Cost (as % of GNI) of Water in 1997 to that in 2003?
Your answer should be compact. 0.8. What is the ratio of the Cost (as % of GNI) of Coal in 1997 to that in 2004?
Your answer should be very brief. 1.08. What is the ratio of the Cost (as % of GNI) in Minerals in 1997 to that in 2004?
Offer a terse response. 1.39. What is the ratio of the Cost (as % of GNI) of Energy in 1997 to that in 2004?
Offer a terse response. 0.66. What is the ratio of the Cost (as % of GNI) of Water in 1997 to that in 2004?
Ensure brevity in your answer.  0.67. What is the ratio of the Cost (as % of GNI) of Coal in 1998 to that in 1999?
Your answer should be very brief. 1.01. What is the ratio of the Cost (as % of GNI) in Minerals in 1998 to that in 1999?
Make the answer very short. 1.3. What is the ratio of the Cost (as % of GNI) in Energy in 1998 to that in 1999?
Give a very brief answer. 1.11. What is the ratio of the Cost (as % of GNI) of Water in 1998 to that in 1999?
Keep it short and to the point. 1.11. What is the ratio of the Cost (as % of GNI) of Coal in 1998 to that in 2000?
Offer a very short reply. 1.01. What is the ratio of the Cost (as % of GNI) in Minerals in 1998 to that in 2000?
Make the answer very short. 1.18. What is the ratio of the Cost (as % of GNI) in Energy in 1998 to that in 2000?
Offer a terse response. 0.32. What is the ratio of the Cost (as % of GNI) in Water in 1998 to that in 2000?
Ensure brevity in your answer.  0.33. What is the ratio of the Cost (as % of GNI) of Coal in 1998 to that in 2001?
Provide a succinct answer. 1.03. What is the ratio of the Cost (as % of GNI) in Minerals in 1998 to that in 2001?
Make the answer very short. 1.69. What is the ratio of the Cost (as % of GNI) of Energy in 1998 to that in 2001?
Keep it short and to the point. 0.4. What is the ratio of the Cost (as % of GNI) of Water in 1998 to that in 2001?
Keep it short and to the point. 0.41. What is the ratio of the Cost (as % of GNI) of Coal in 1998 to that in 2002?
Your answer should be very brief. 1.03. What is the ratio of the Cost (as % of GNI) of Minerals in 1998 to that in 2002?
Give a very brief answer. 1.98. What is the ratio of the Cost (as % of GNI) in Energy in 1998 to that in 2002?
Your response must be concise. 0.56. What is the ratio of the Cost (as % of GNI) of Water in 1998 to that in 2002?
Your answer should be compact. 0.57. What is the ratio of the Cost (as % of GNI) of Coal in 1998 to that in 2003?
Your response must be concise. 1.03. What is the ratio of the Cost (as % of GNI) in Minerals in 1998 to that in 2003?
Your answer should be very brief. 1.78. What is the ratio of the Cost (as % of GNI) of Energy in 1998 to that in 2003?
Make the answer very short. 0.35. What is the ratio of the Cost (as % of GNI) of Water in 1998 to that in 2003?
Your response must be concise. 0.36. What is the ratio of the Cost (as % of GNI) of Coal in 1998 to that in 2004?
Provide a succinct answer. 1.05. What is the ratio of the Cost (as % of GNI) of Minerals in 1998 to that in 2004?
Offer a terse response. 0.73. What is the ratio of the Cost (as % of GNI) of Energy in 1998 to that in 2004?
Ensure brevity in your answer.  0.29. What is the ratio of the Cost (as % of GNI) in Water in 1998 to that in 2004?
Give a very brief answer. 0.3. What is the ratio of the Cost (as % of GNI) of Minerals in 1999 to that in 2000?
Provide a short and direct response. 0.9. What is the ratio of the Cost (as % of GNI) of Energy in 1999 to that in 2000?
Your answer should be very brief. 0.29. What is the ratio of the Cost (as % of GNI) of Water in 1999 to that in 2000?
Ensure brevity in your answer.  0.3. What is the ratio of the Cost (as % of GNI) of Coal in 1999 to that in 2001?
Ensure brevity in your answer.  1.02. What is the ratio of the Cost (as % of GNI) of Minerals in 1999 to that in 2001?
Keep it short and to the point. 1.3. What is the ratio of the Cost (as % of GNI) in Energy in 1999 to that in 2001?
Your answer should be compact. 0.36. What is the ratio of the Cost (as % of GNI) of Water in 1999 to that in 2001?
Provide a succinct answer. 0.37. What is the ratio of the Cost (as % of GNI) in Coal in 1999 to that in 2002?
Give a very brief answer. 1.01. What is the ratio of the Cost (as % of GNI) of Minerals in 1999 to that in 2002?
Provide a short and direct response. 1.52. What is the ratio of the Cost (as % of GNI) of Energy in 1999 to that in 2002?
Keep it short and to the point. 0.5. What is the ratio of the Cost (as % of GNI) in Water in 1999 to that in 2002?
Ensure brevity in your answer.  0.52. What is the ratio of the Cost (as % of GNI) of Coal in 1999 to that in 2003?
Offer a very short reply. 1.02. What is the ratio of the Cost (as % of GNI) in Minerals in 1999 to that in 2003?
Offer a terse response. 1.36. What is the ratio of the Cost (as % of GNI) of Energy in 1999 to that in 2003?
Your answer should be very brief. 0.31. What is the ratio of the Cost (as % of GNI) of Water in 1999 to that in 2003?
Keep it short and to the point. 0.32. What is the ratio of the Cost (as % of GNI) in Coal in 1999 to that in 2004?
Your answer should be very brief. 1.03. What is the ratio of the Cost (as % of GNI) in Minerals in 1999 to that in 2004?
Provide a succinct answer. 0.56. What is the ratio of the Cost (as % of GNI) in Energy in 1999 to that in 2004?
Your response must be concise. 0.26. What is the ratio of the Cost (as % of GNI) of Water in 1999 to that in 2004?
Make the answer very short. 0.27. What is the ratio of the Cost (as % of GNI) in Coal in 2000 to that in 2001?
Provide a succinct answer. 1.02. What is the ratio of the Cost (as % of GNI) in Minerals in 2000 to that in 2001?
Offer a very short reply. 1.44. What is the ratio of the Cost (as % of GNI) in Energy in 2000 to that in 2001?
Your answer should be very brief. 1.23. What is the ratio of the Cost (as % of GNI) of Water in 2000 to that in 2001?
Your answer should be very brief. 1.23. What is the ratio of the Cost (as % of GNI) in Coal in 2000 to that in 2002?
Your answer should be very brief. 1.01. What is the ratio of the Cost (as % of GNI) of Minerals in 2000 to that in 2002?
Ensure brevity in your answer.  1.68. What is the ratio of the Cost (as % of GNI) of Energy in 2000 to that in 2002?
Your answer should be very brief. 1.72. What is the ratio of the Cost (as % of GNI) of Water in 2000 to that in 2002?
Your answer should be very brief. 1.72. What is the ratio of the Cost (as % of GNI) of Minerals in 2000 to that in 2003?
Provide a short and direct response. 1.51. What is the ratio of the Cost (as % of GNI) of Energy in 2000 to that in 2003?
Your response must be concise. 1.07. What is the ratio of the Cost (as % of GNI) of Water in 2000 to that in 2003?
Offer a terse response. 1.07. What is the ratio of the Cost (as % of GNI) of Minerals in 2000 to that in 2004?
Offer a very short reply. 0.62. What is the ratio of the Cost (as % of GNI) in Energy in 2000 to that in 2004?
Provide a succinct answer. 0.9. What is the ratio of the Cost (as % of GNI) of Water in 2000 to that in 2004?
Your answer should be compact. 0.89. What is the ratio of the Cost (as % of GNI) of Minerals in 2001 to that in 2002?
Give a very brief answer. 1.17. What is the ratio of the Cost (as % of GNI) in Energy in 2001 to that in 2002?
Provide a short and direct response. 1.4. What is the ratio of the Cost (as % of GNI) of Water in 2001 to that in 2002?
Offer a very short reply. 1.4. What is the ratio of the Cost (as % of GNI) of Minerals in 2001 to that in 2003?
Offer a terse response. 1.05. What is the ratio of the Cost (as % of GNI) in Energy in 2001 to that in 2003?
Offer a very short reply. 0.87. What is the ratio of the Cost (as % of GNI) in Water in 2001 to that in 2003?
Your answer should be very brief. 0.87. What is the ratio of the Cost (as % of GNI) of Coal in 2001 to that in 2004?
Your answer should be compact. 1.01. What is the ratio of the Cost (as % of GNI) of Minerals in 2001 to that in 2004?
Provide a short and direct response. 0.43. What is the ratio of the Cost (as % of GNI) of Energy in 2001 to that in 2004?
Give a very brief answer. 0.73. What is the ratio of the Cost (as % of GNI) of Water in 2001 to that in 2004?
Provide a succinct answer. 0.73. What is the ratio of the Cost (as % of GNI) of Coal in 2002 to that in 2003?
Offer a terse response. 1.01. What is the ratio of the Cost (as % of GNI) of Minerals in 2002 to that in 2003?
Keep it short and to the point. 0.9. What is the ratio of the Cost (as % of GNI) in Energy in 2002 to that in 2003?
Your response must be concise. 0.62. What is the ratio of the Cost (as % of GNI) of Water in 2002 to that in 2003?
Your answer should be very brief. 0.62. What is the ratio of the Cost (as % of GNI) of Coal in 2002 to that in 2004?
Ensure brevity in your answer.  1.02. What is the ratio of the Cost (as % of GNI) in Minerals in 2002 to that in 2004?
Your answer should be compact. 0.37. What is the ratio of the Cost (as % of GNI) in Energy in 2002 to that in 2004?
Offer a terse response. 0.52. What is the ratio of the Cost (as % of GNI) of Water in 2002 to that in 2004?
Keep it short and to the point. 0.52. What is the ratio of the Cost (as % of GNI) in Coal in 2003 to that in 2004?
Offer a very short reply. 1.01. What is the ratio of the Cost (as % of GNI) in Minerals in 2003 to that in 2004?
Offer a very short reply. 0.41. What is the ratio of the Cost (as % of GNI) in Energy in 2003 to that in 2004?
Offer a terse response. 0.84. What is the ratio of the Cost (as % of GNI) of Water in 2003 to that in 2004?
Provide a short and direct response. 0.84. What is the difference between the highest and the second highest Cost (as % of GNI) of Coal?
Provide a succinct answer. 0.01. What is the difference between the highest and the second highest Cost (as % of GNI) of Minerals?
Provide a succinct answer. 0.01. What is the difference between the highest and the second highest Cost (as % of GNI) in Energy?
Provide a short and direct response. 0.08. What is the difference between the highest and the second highest Cost (as % of GNI) in Water?
Provide a short and direct response. 0.08. What is the difference between the highest and the lowest Cost (as % of GNI) in Coal?
Provide a succinct answer. 0.03. What is the difference between the highest and the lowest Cost (as % of GNI) in Minerals?
Ensure brevity in your answer.  0.01. What is the difference between the highest and the lowest Cost (as % of GNI) of Energy?
Your answer should be compact. 0.55. What is the difference between the highest and the lowest Cost (as % of GNI) in Water?
Provide a succinct answer. 0.56. 